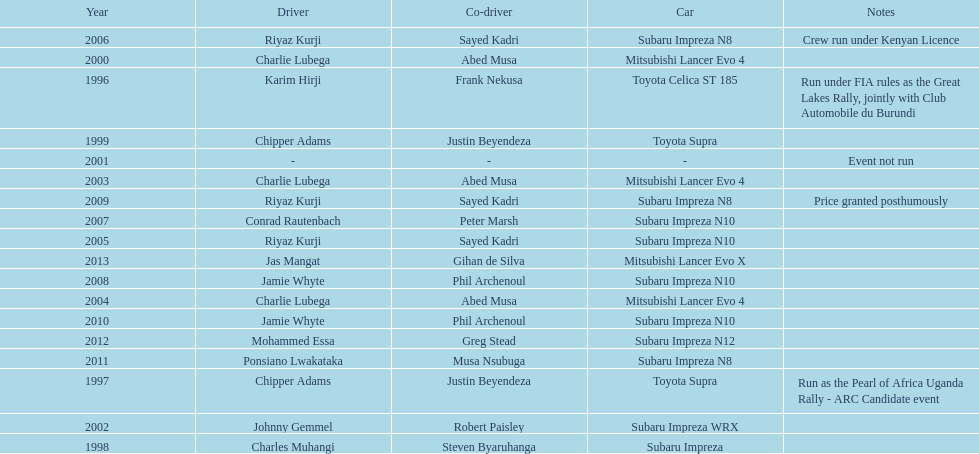Who was the only driver to win in a car other than a subaru impreza after the year 2005? Jas Mangat. 